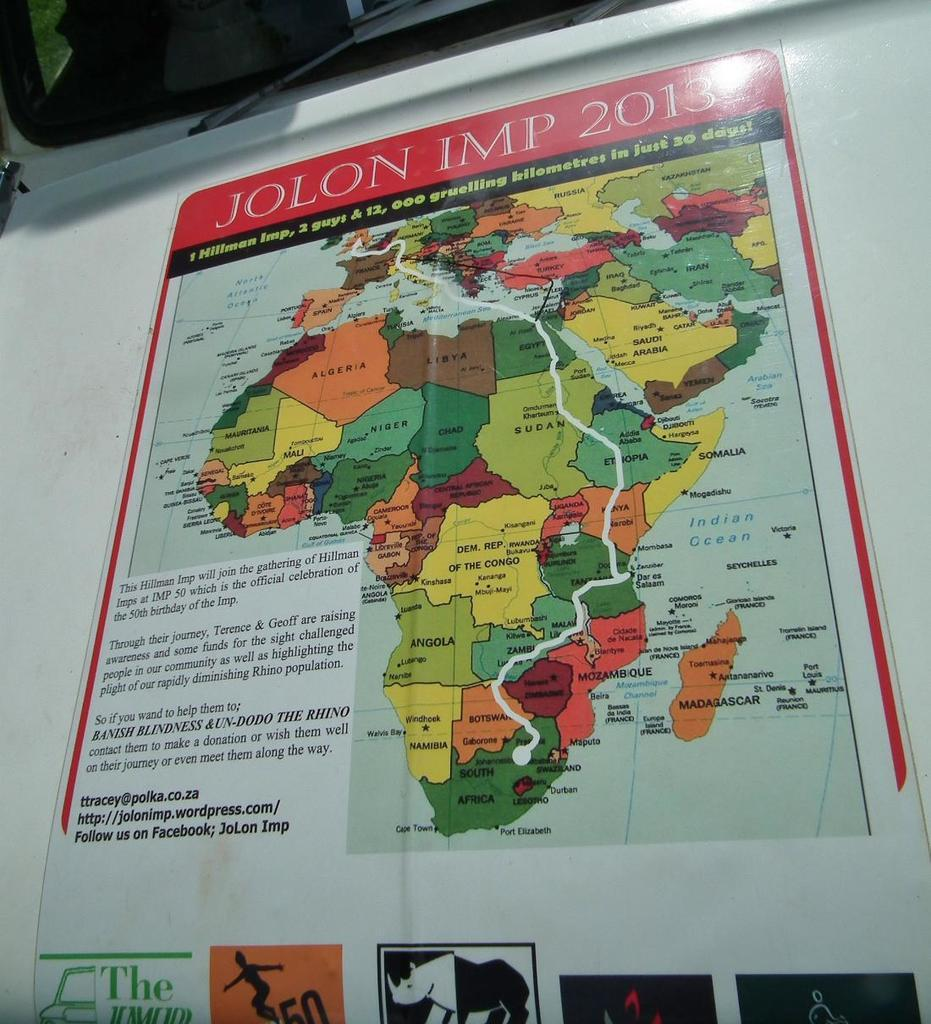Provide a one-sentence caption for the provided image. A poster of Africa says "JOLON IMP 2013" at the top. 